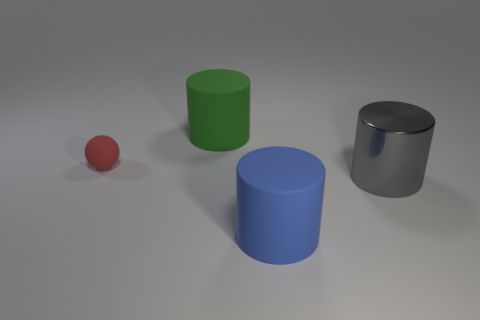Add 4 small objects. How many objects exist? 8 Subtract all cylinders. How many objects are left? 1 Subtract all blue rubber things. Subtract all metallic objects. How many objects are left? 2 Add 4 big blue objects. How many big blue objects are left? 5 Add 1 tiny spheres. How many tiny spheres exist? 2 Subtract 0 cyan cylinders. How many objects are left? 4 